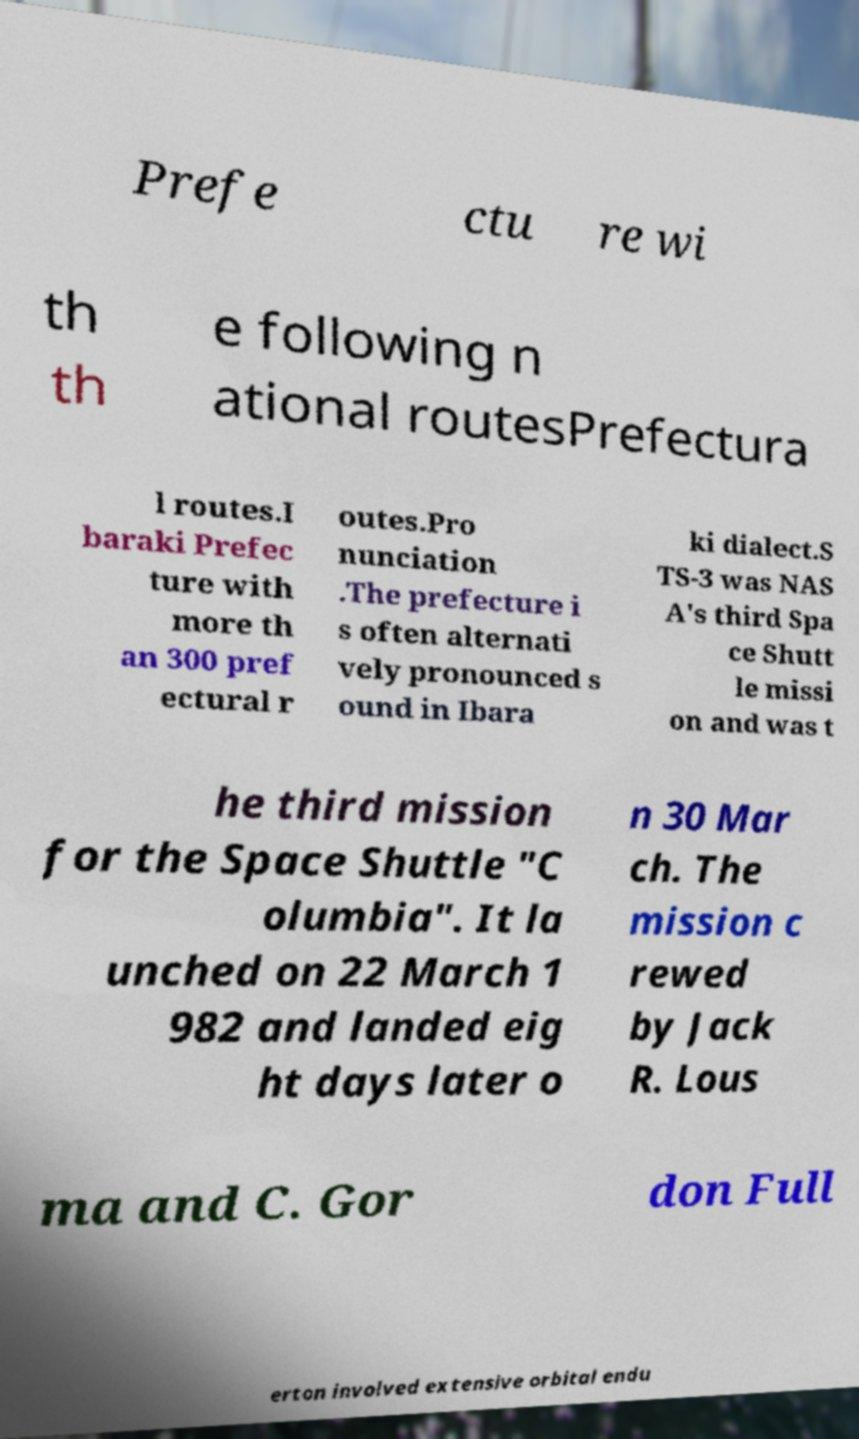Could you extract and type out the text from this image? Prefe ctu re wi th th e following n ational routesPrefectura l routes.I baraki Prefec ture with more th an 300 pref ectural r outes.Pro nunciation .The prefecture i s often alternati vely pronounced s ound in Ibara ki dialect.S TS-3 was NAS A's third Spa ce Shutt le missi on and was t he third mission for the Space Shuttle "C olumbia". It la unched on 22 March 1 982 and landed eig ht days later o n 30 Mar ch. The mission c rewed by Jack R. Lous ma and C. Gor don Full erton involved extensive orbital endu 